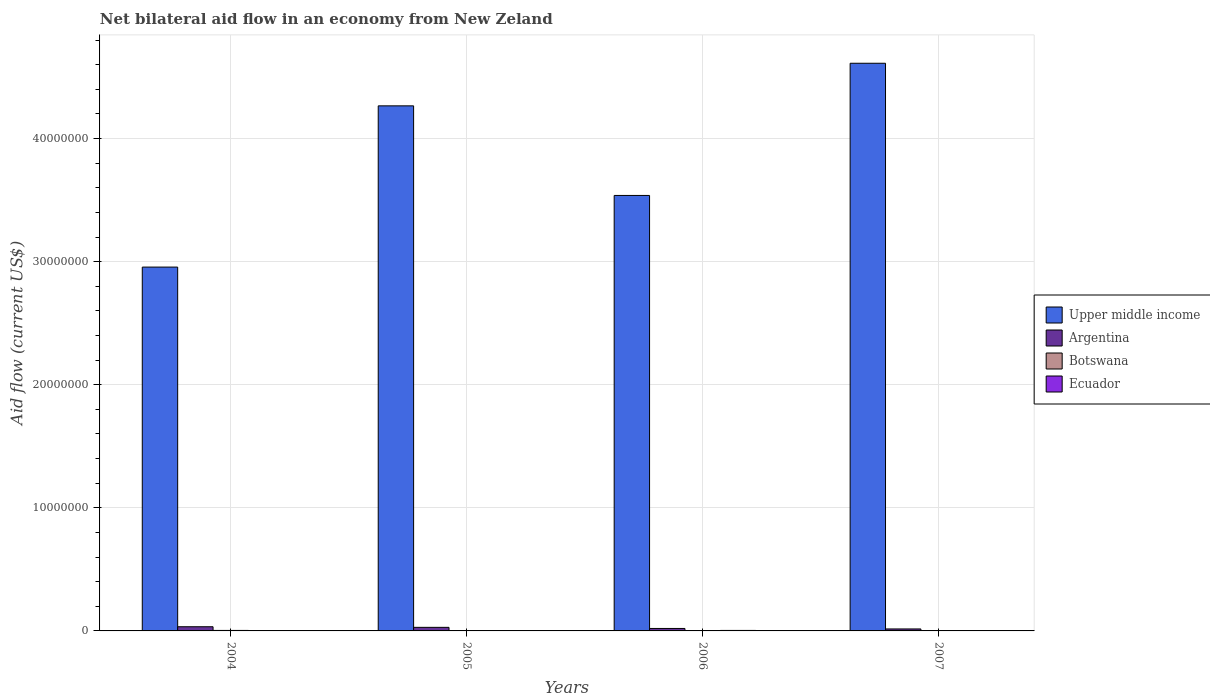How many groups of bars are there?
Give a very brief answer. 4. In how many cases, is the number of bars for a given year not equal to the number of legend labels?
Offer a very short reply. 0. What is the net bilateral aid flow in Upper middle income in 2004?
Give a very brief answer. 2.96e+07. Across all years, what is the minimum net bilateral aid flow in Argentina?
Keep it short and to the point. 1.60e+05. In which year was the net bilateral aid flow in Upper middle income minimum?
Provide a short and direct response. 2004. What is the total net bilateral aid flow in Ecuador in the graph?
Your response must be concise. 1.20e+05. What is the difference between the net bilateral aid flow in Argentina in 2006 and that in 2007?
Ensure brevity in your answer.  4.00e+04. What is the difference between the net bilateral aid flow in Argentina in 2005 and the net bilateral aid flow in Botswana in 2004?
Keep it short and to the point. 2.50e+05. What is the average net bilateral aid flow in Argentina per year?
Make the answer very short. 2.48e+05. In the year 2006, what is the difference between the net bilateral aid flow in Argentina and net bilateral aid flow in Botswana?
Offer a terse response. 1.80e+05. In how many years, is the net bilateral aid flow in Botswana greater than 44000000 US$?
Make the answer very short. 0. What is the ratio of the net bilateral aid flow in Argentina in 2004 to that in 2007?
Offer a very short reply. 2.12. Is the net bilateral aid flow in Botswana in 2004 less than that in 2007?
Provide a short and direct response. No. What is the difference between the highest and the lowest net bilateral aid flow in Botswana?
Ensure brevity in your answer.  2.00e+04. Is the sum of the net bilateral aid flow in Ecuador in 2005 and 2007 greater than the maximum net bilateral aid flow in Botswana across all years?
Give a very brief answer. Yes. What does the 3rd bar from the left in 2005 represents?
Your answer should be very brief. Botswana. What does the 4th bar from the right in 2004 represents?
Keep it short and to the point. Upper middle income. How many bars are there?
Your answer should be very brief. 16. What is the difference between two consecutive major ticks on the Y-axis?
Provide a succinct answer. 1.00e+07. Does the graph contain grids?
Keep it short and to the point. Yes. Where does the legend appear in the graph?
Give a very brief answer. Center right. How many legend labels are there?
Your answer should be very brief. 4. How are the legend labels stacked?
Provide a short and direct response. Vertical. What is the title of the graph?
Make the answer very short. Net bilateral aid flow in an economy from New Zeland. What is the Aid flow (current US$) in Upper middle income in 2004?
Your answer should be very brief. 2.96e+07. What is the Aid flow (current US$) in Argentina in 2004?
Make the answer very short. 3.40e+05. What is the Aid flow (current US$) of Upper middle income in 2005?
Provide a short and direct response. 4.27e+07. What is the Aid flow (current US$) in Ecuador in 2005?
Offer a terse response. 3.00e+04. What is the Aid flow (current US$) in Upper middle income in 2006?
Keep it short and to the point. 3.54e+07. What is the Aid flow (current US$) in Botswana in 2006?
Offer a terse response. 2.00e+04. What is the Aid flow (current US$) of Upper middle income in 2007?
Give a very brief answer. 4.61e+07. What is the Aid flow (current US$) of Argentina in 2007?
Provide a succinct answer. 1.60e+05. What is the Aid flow (current US$) of Ecuador in 2007?
Keep it short and to the point. 2.00e+04. Across all years, what is the maximum Aid flow (current US$) in Upper middle income?
Your response must be concise. 4.61e+07. Across all years, what is the maximum Aid flow (current US$) in Argentina?
Make the answer very short. 3.40e+05. Across all years, what is the minimum Aid flow (current US$) of Upper middle income?
Your answer should be very brief. 2.96e+07. What is the total Aid flow (current US$) in Upper middle income in the graph?
Provide a succinct answer. 1.54e+08. What is the total Aid flow (current US$) of Argentina in the graph?
Your answer should be compact. 9.90e+05. What is the difference between the Aid flow (current US$) of Upper middle income in 2004 and that in 2005?
Offer a very short reply. -1.31e+07. What is the difference between the Aid flow (current US$) in Argentina in 2004 and that in 2005?
Your response must be concise. 5.00e+04. What is the difference between the Aid flow (current US$) of Ecuador in 2004 and that in 2005?
Offer a very short reply. 0. What is the difference between the Aid flow (current US$) in Upper middle income in 2004 and that in 2006?
Make the answer very short. -5.82e+06. What is the difference between the Aid flow (current US$) in Botswana in 2004 and that in 2006?
Offer a terse response. 2.00e+04. What is the difference between the Aid flow (current US$) in Ecuador in 2004 and that in 2006?
Provide a succinct answer. -10000. What is the difference between the Aid flow (current US$) of Upper middle income in 2004 and that in 2007?
Offer a terse response. -1.66e+07. What is the difference between the Aid flow (current US$) of Ecuador in 2004 and that in 2007?
Provide a succinct answer. 10000. What is the difference between the Aid flow (current US$) in Upper middle income in 2005 and that in 2006?
Keep it short and to the point. 7.28e+06. What is the difference between the Aid flow (current US$) of Argentina in 2005 and that in 2006?
Keep it short and to the point. 9.00e+04. What is the difference between the Aid flow (current US$) of Botswana in 2005 and that in 2006?
Offer a very short reply. 10000. What is the difference between the Aid flow (current US$) in Upper middle income in 2005 and that in 2007?
Make the answer very short. -3.46e+06. What is the difference between the Aid flow (current US$) in Argentina in 2005 and that in 2007?
Provide a short and direct response. 1.30e+05. What is the difference between the Aid flow (current US$) of Botswana in 2005 and that in 2007?
Ensure brevity in your answer.  10000. What is the difference between the Aid flow (current US$) of Upper middle income in 2006 and that in 2007?
Your answer should be very brief. -1.07e+07. What is the difference between the Aid flow (current US$) of Ecuador in 2006 and that in 2007?
Provide a short and direct response. 2.00e+04. What is the difference between the Aid flow (current US$) in Upper middle income in 2004 and the Aid flow (current US$) in Argentina in 2005?
Your response must be concise. 2.93e+07. What is the difference between the Aid flow (current US$) in Upper middle income in 2004 and the Aid flow (current US$) in Botswana in 2005?
Provide a short and direct response. 2.95e+07. What is the difference between the Aid flow (current US$) in Upper middle income in 2004 and the Aid flow (current US$) in Ecuador in 2005?
Give a very brief answer. 2.95e+07. What is the difference between the Aid flow (current US$) of Argentina in 2004 and the Aid flow (current US$) of Botswana in 2005?
Your answer should be very brief. 3.10e+05. What is the difference between the Aid flow (current US$) in Upper middle income in 2004 and the Aid flow (current US$) in Argentina in 2006?
Keep it short and to the point. 2.94e+07. What is the difference between the Aid flow (current US$) in Upper middle income in 2004 and the Aid flow (current US$) in Botswana in 2006?
Keep it short and to the point. 2.95e+07. What is the difference between the Aid flow (current US$) in Upper middle income in 2004 and the Aid flow (current US$) in Ecuador in 2006?
Provide a succinct answer. 2.95e+07. What is the difference between the Aid flow (current US$) in Botswana in 2004 and the Aid flow (current US$) in Ecuador in 2006?
Make the answer very short. 0. What is the difference between the Aid flow (current US$) in Upper middle income in 2004 and the Aid flow (current US$) in Argentina in 2007?
Ensure brevity in your answer.  2.94e+07. What is the difference between the Aid flow (current US$) of Upper middle income in 2004 and the Aid flow (current US$) of Botswana in 2007?
Ensure brevity in your answer.  2.95e+07. What is the difference between the Aid flow (current US$) of Upper middle income in 2004 and the Aid flow (current US$) of Ecuador in 2007?
Ensure brevity in your answer.  2.95e+07. What is the difference between the Aid flow (current US$) of Argentina in 2004 and the Aid flow (current US$) of Botswana in 2007?
Provide a succinct answer. 3.20e+05. What is the difference between the Aid flow (current US$) in Botswana in 2004 and the Aid flow (current US$) in Ecuador in 2007?
Provide a short and direct response. 2.00e+04. What is the difference between the Aid flow (current US$) of Upper middle income in 2005 and the Aid flow (current US$) of Argentina in 2006?
Your answer should be compact. 4.25e+07. What is the difference between the Aid flow (current US$) of Upper middle income in 2005 and the Aid flow (current US$) of Botswana in 2006?
Your answer should be compact. 4.26e+07. What is the difference between the Aid flow (current US$) in Upper middle income in 2005 and the Aid flow (current US$) in Ecuador in 2006?
Give a very brief answer. 4.26e+07. What is the difference between the Aid flow (current US$) in Botswana in 2005 and the Aid flow (current US$) in Ecuador in 2006?
Give a very brief answer. -10000. What is the difference between the Aid flow (current US$) of Upper middle income in 2005 and the Aid flow (current US$) of Argentina in 2007?
Ensure brevity in your answer.  4.25e+07. What is the difference between the Aid flow (current US$) in Upper middle income in 2005 and the Aid flow (current US$) in Botswana in 2007?
Ensure brevity in your answer.  4.26e+07. What is the difference between the Aid flow (current US$) in Upper middle income in 2005 and the Aid flow (current US$) in Ecuador in 2007?
Ensure brevity in your answer.  4.26e+07. What is the difference between the Aid flow (current US$) in Argentina in 2005 and the Aid flow (current US$) in Botswana in 2007?
Keep it short and to the point. 2.70e+05. What is the difference between the Aid flow (current US$) in Botswana in 2005 and the Aid flow (current US$) in Ecuador in 2007?
Make the answer very short. 10000. What is the difference between the Aid flow (current US$) in Upper middle income in 2006 and the Aid flow (current US$) in Argentina in 2007?
Ensure brevity in your answer.  3.52e+07. What is the difference between the Aid flow (current US$) in Upper middle income in 2006 and the Aid flow (current US$) in Botswana in 2007?
Provide a short and direct response. 3.54e+07. What is the difference between the Aid flow (current US$) of Upper middle income in 2006 and the Aid flow (current US$) of Ecuador in 2007?
Provide a succinct answer. 3.54e+07. What is the difference between the Aid flow (current US$) of Argentina in 2006 and the Aid flow (current US$) of Botswana in 2007?
Provide a succinct answer. 1.80e+05. What is the difference between the Aid flow (current US$) in Argentina in 2006 and the Aid flow (current US$) in Ecuador in 2007?
Provide a short and direct response. 1.80e+05. What is the average Aid flow (current US$) in Upper middle income per year?
Make the answer very short. 3.84e+07. What is the average Aid flow (current US$) of Argentina per year?
Offer a terse response. 2.48e+05. What is the average Aid flow (current US$) in Botswana per year?
Provide a short and direct response. 2.75e+04. What is the average Aid flow (current US$) in Ecuador per year?
Give a very brief answer. 3.00e+04. In the year 2004, what is the difference between the Aid flow (current US$) of Upper middle income and Aid flow (current US$) of Argentina?
Offer a very short reply. 2.92e+07. In the year 2004, what is the difference between the Aid flow (current US$) of Upper middle income and Aid flow (current US$) of Botswana?
Keep it short and to the point. 2.95e+07. In the year 2004, what is the difference between the Aid flow (current US$) of Upper middle income and Aid flow (current US$) of Ecuador?
Ensure brevity in your answer.  2.95e+07. In the year 2004, what is the difference between the Aid flow (current US$) of Argentina and Aid flow (current US$) of Botswana?
Provide a succinct answer. 3.00e+05. In the year 2004, what is the difference between the Aid flow (current US$) in Argentina and Aid flow (current US$) in Ecuador?
Provide a short and direct response. 3.10e+05. In the year 2004, what is the difference between the Aid flow (current US$) of Botswana and Aid flow (current US$) of Ecuador?
Your response must be concise. 10000. In the year 2005, what is the difference between the Aid flow (current US$) of Upper middle income and Aid flow (current US$) of Argentina?
Make the answer very short. 4.24e+07. In the year 2005, what is the difference between the Aid flow (current US$) in Upper middle income and Aid flow (current US$) in Botswana?
Ensure brevity in your answer.  4.26e+07. In the year 2005, what is the difference between the Aid flow (current US$) in Upper middle income and Aid flow (current US$) in Ecuador?
Keep it short and to the point. 4.26e+07. In the year 2005, what is the difference between the Aid flow (current US$) in Argentina and Aid flow (current US$) in Ecuador?
Provide a succinct answer. 2.60e+05. In the year 2006, what is the difference between the Aid flow (current US$) of Upper middle income and Aid flow (current US$) of Argentina?
Keep it short and to the point. 3.52e+07. In the year 2006, what is the difference between the Aid flow (current US$) of Upper middle income and Aid flow (current US$) of Botswana?
Provide a succinct answer. 3.54e+07. In the year 2006, what is the difference between the Aid flow (current US$) in Upper middle income and Aid flow (current US$) in Ecuador?
Ensure brevity in your answer.  3.53e+07. In the year 2006, what is the difference between the Aid flow (current US$) in Argentina and Aid flow (current US$) in Botswana?
Your answer should be compact. 1.80e+05. In the year 2006, what is the difference between the Aid flow (current US$) of Argentina and Aid flow (current US$) of Ecuador?
Keep it short and to the point. 1.60e+05. In the year 2006, what is the difference between the Aid flow (current US$) in Botswana and Aid flow (current US$) in Ecuador?
Provide a succinct answer. -2.00e+04. In the year 2007, what is the difference between the Aid flow (current US$) of Upper middle income and Aid flow (current US$) of Argentina?
Keep it short and to the point. 4.60e+07. In the year 2007, what is the difference between the Aid flow (current US$) of Upper middle income and Aid flow (current US$) of Botswana?
Give a very brief answer. 4.61e+07. In the year 2007, what is the difference between the Aid flow (current US$) in Upper middle income and Aid flow (current US$) in Ecuador?
Your answer should be compact. 4.61e+07. In the year 2007, what is the difference between the Aid flow (current US$) in Argentina and Aid flow (current US$) in Ecuador?
Your response must be concise. 1.40e+05. What is the ratio of the Aid flow (current US$) in Upper middle income in 2004 to that in 2005?
Give a very brief answer. 0.69. What is the ratio of the Aid flow (current US$) in Argentina in 2004 to that in 2005?
Offer a terse response. 1.17. What is the ratio of the Aid flow (current US$) in Botswana in 2004 to that in 2005?
Offer a very short reply. 1.33. What is the ratio of the Aid flow (current US$) of Ecuador in 2004 to that in 2005?
Your answer should be compact. 1. What is the ratio of the Aid flow (current US$) of Upper middle income in 2004 to that in 2006?
Offer a very short reply. 0.84. What is the ratio of the Aid flow (current US$) in Ecuador in 2004 to that in 2006?
Make the answer very short. 0.75. What is the ratio of the Aid flow (current US$) of Upper middle income in 2004 to that in 2007?
Keep it short and to the point. 0.64. What is the ratio of the Aid flow (current US$) of Argentina in 2004 to that in 2007?
Give a very brief answer. 2.12. What is the ratio of the Aid flow (current US$) of Botswana in 2004 to that in 2007?
Offer a terse response. 2. What is the ratio of the Aid flow (current US$) of Upper middle income in 2005 to that in 2006?
Your answer should be very brief. 1.21. What is the ratio of the Aid flow (current US$) of Argentina in 2005 to that in 2006?
Your answer should be very brief. 1.45. What is the ratio of the Aid flow (current US$) in Upper middle income in 2005 to that in 2007?
Provide a succinct answer. 0.93. What is the ratio of the Aid flow (current US$) in Argentina in 2005 to that in 2007?
Ensure brevity in your answer.  1.81. What is the ratio of the Aid flow (current US$) in Botswana in 2005 to that in 2007?
Your answer should be compact. 1.5. What is the ratio of the Aid flow (current US$) in Upper middle income in 2006 to that in 2007?
Your answer should be very brief. 0.77. What is the ratio of the Aid flow (current US$) in Argentina in 2006 to that in 2007?
Your answer should be compact. 1.25. What is the difference between the highest and the second highest Aid flow (current US$) of Upper middle income?
Your answer should be compact. 3.46e+06. What is the difference between the highest and the second highest Aid flow (current US$) in Argentina?
Keep it short and to the point. 5.00e+04. What is the difference between the highest and the second highest Aid flow (current US$) in Botswana?
Provide a short and direct response. 10000. What is the difference between the highest and the second highest Aid flow (current US$) in Ecuador?
Provide a succinct answer. 10000. What is the difference between the highest and the lowest Aid flow (current US$) of Upper middle income?
Provide a succinct answer. 1.66e+07. What is the difference between the highest and the lowest Aid flow (current US$) of Argentina?
Offer a terse response. 1.80e+05. What is the difference between the highest and the lowest Aid flow (current US$) in Ecuador?
Your answer should be compact. 2.00e+04. 